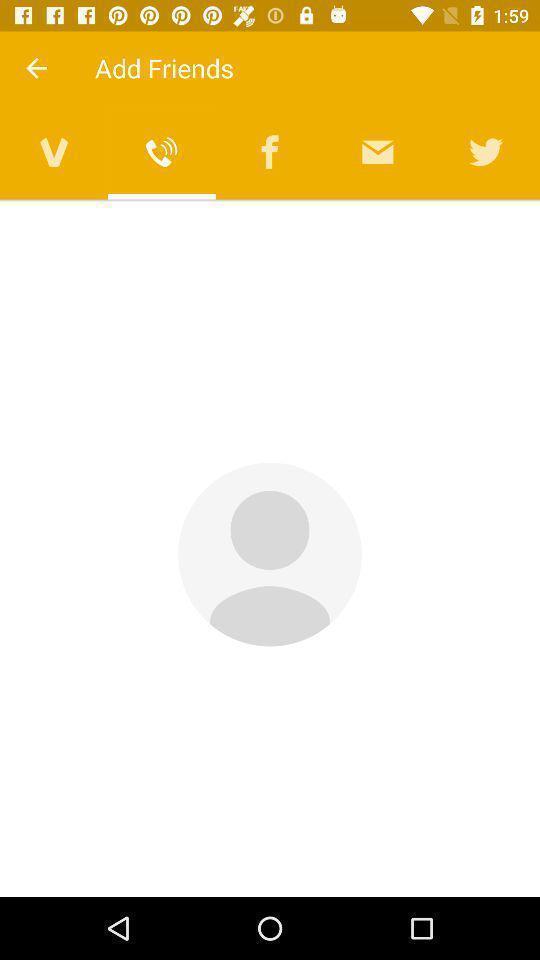Provide a description of this screenshot. No friends list in add friends. 